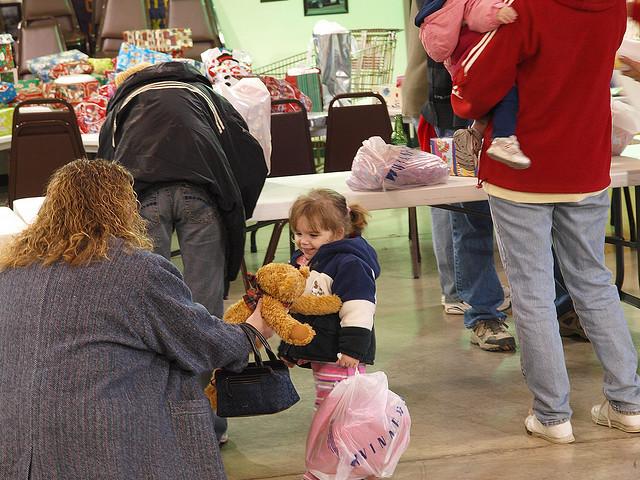What color is the bear?
Give a very brief answer. Brown. How many people have stripes on their jackets?
Write a very short answer. 3. Is the woman giving the teddy bear to the girl?
Quick response, please. Yes. 